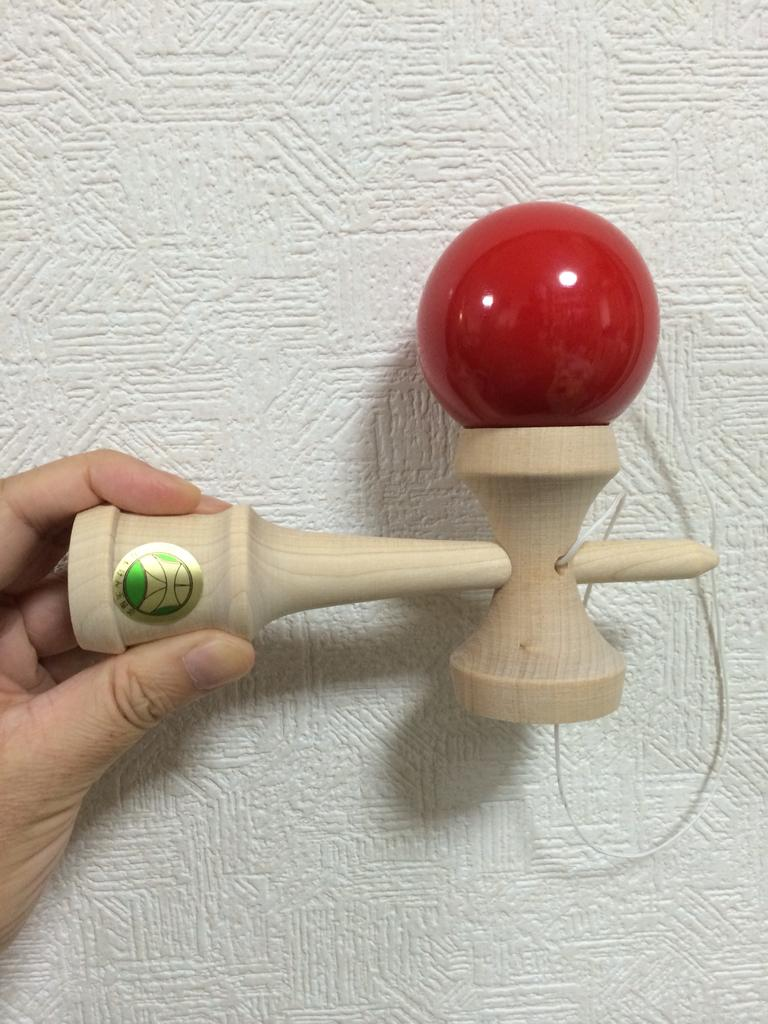What is the person's hand holding in the image? The person's hand is holding an object that resembles a hammer in the image. Can you describe the hammer in more detail? Yes, there is a red color ball on the hammer. What can be seen in the background of the image? There are designs on the wall in the background of the image. How does the growth of the spot affect the fuel consumption in the image? There is no mention of a spot or fuel consumption in the image; it features a person's hand holding a hammer with a red color ball on it. 